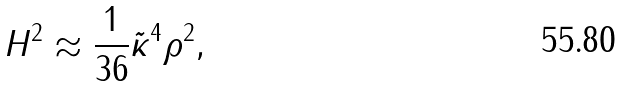Convert formula to latex. <formula><loc_0><loc_0><loc_500><loc_500>H ^ { 2 } \approx \frac { 1 } { 3 6 } \tilde { \kappa } ^ { 4 } \rho ^ { 2 } ,</formula> 